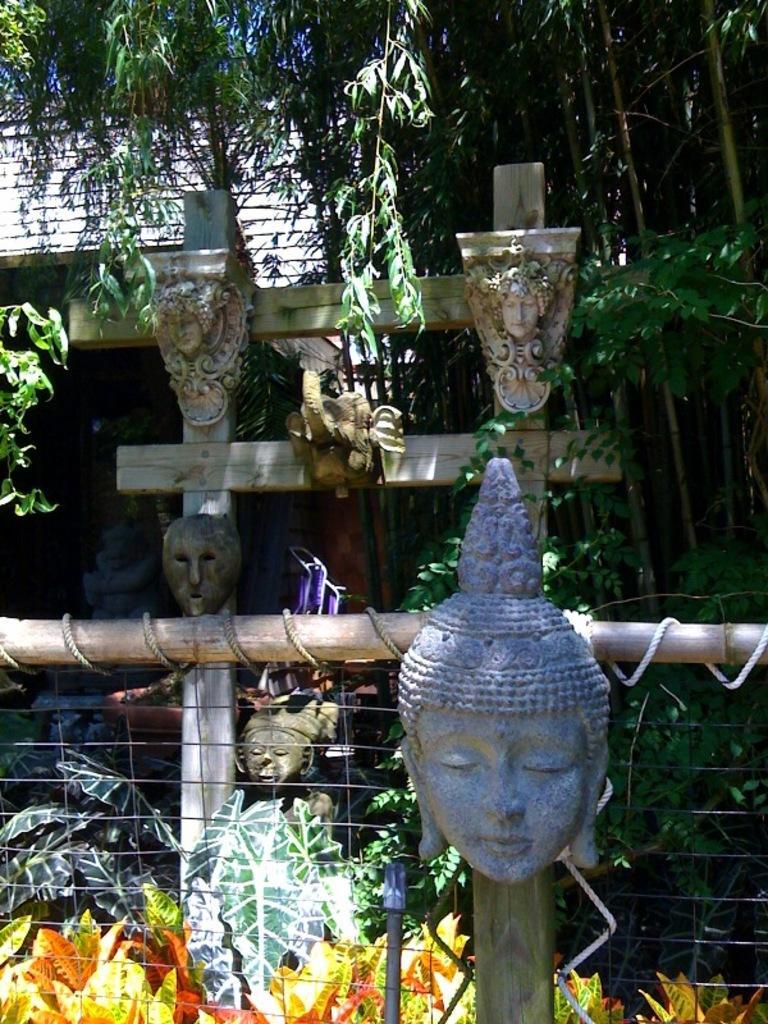Can you describe this image briefly? In this image there are sculptures. At the bottom there is a fence and we can see plants. In the background there are trees and we can see a shed. 